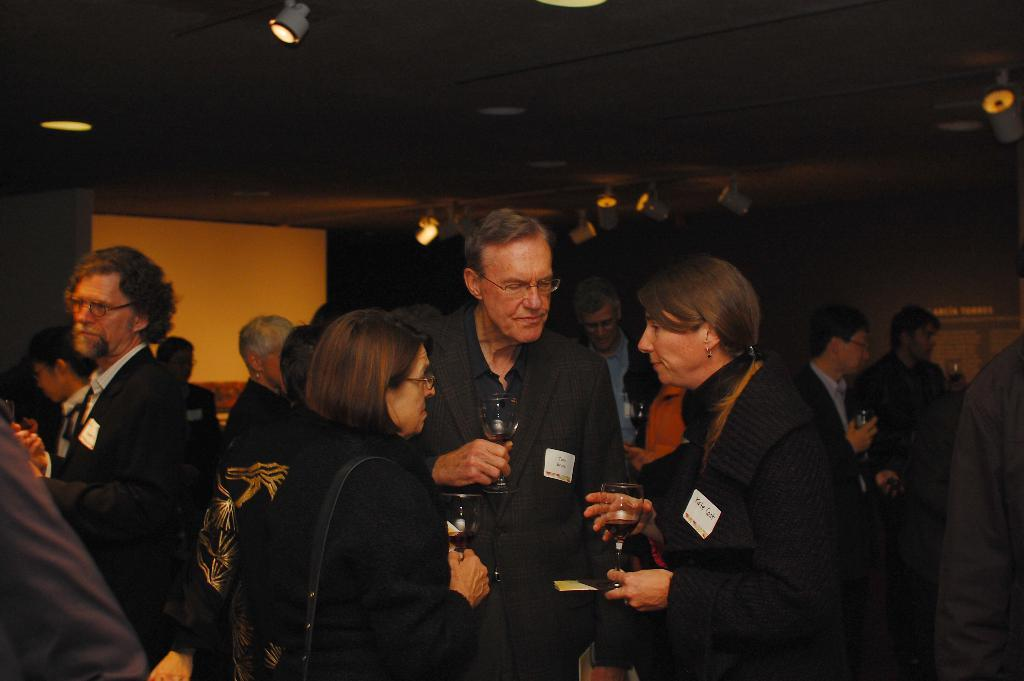What are the people in the image doing? The people in the image are standing in the center and holding wine glasses. What can be seen in the background of the image? There is a wall, a roof, a board, and lights in the background of the image. What type of temper can be seen in the people standing in the image? There is no indication of the people's temper in the image; they are simply holding wine glasses. What shape is the board in the background of the image? The shape of the board in the background of the image cannot be determined from the image. 